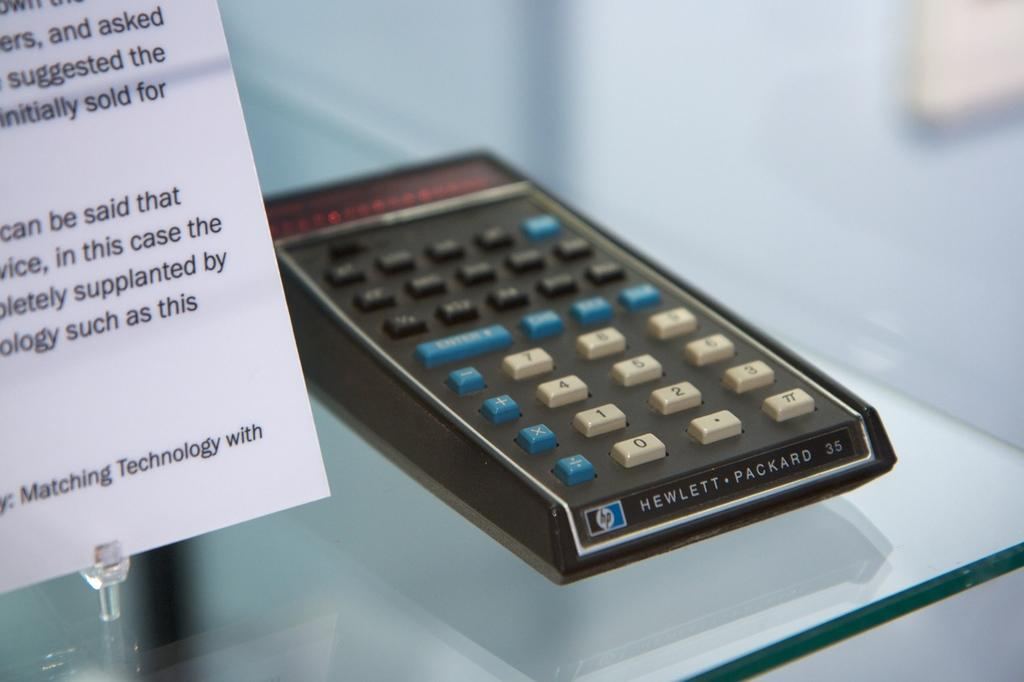<image>
Summarize the visual content of the image. A vintage Hewlett Packard calculater with a sign next to it. 